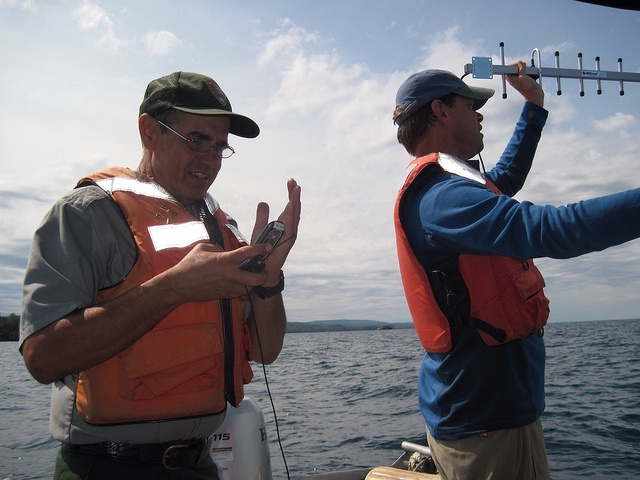Describe the objects in this image and their specific colors. I can see people in lightgray, black, maroon, gray, and white tones, people in lightgray, black, maroon, blue, and navy tones, and cell phone in lightgray, black, and gray tones in this image. 